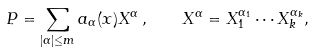<formula> <loc_0><loc_0><loc_500><loc_500>P = \sum _ { | \alpha | \leq m } a _ { \alpha } ( x ) X ^ { \alpha } \, , \quad X ^ { \alpha } = X _ { 1 } ^ { \alpha _ { 1 } } \cdots X _ { k } ^ { \alpha _ { k } } ,</formula> 